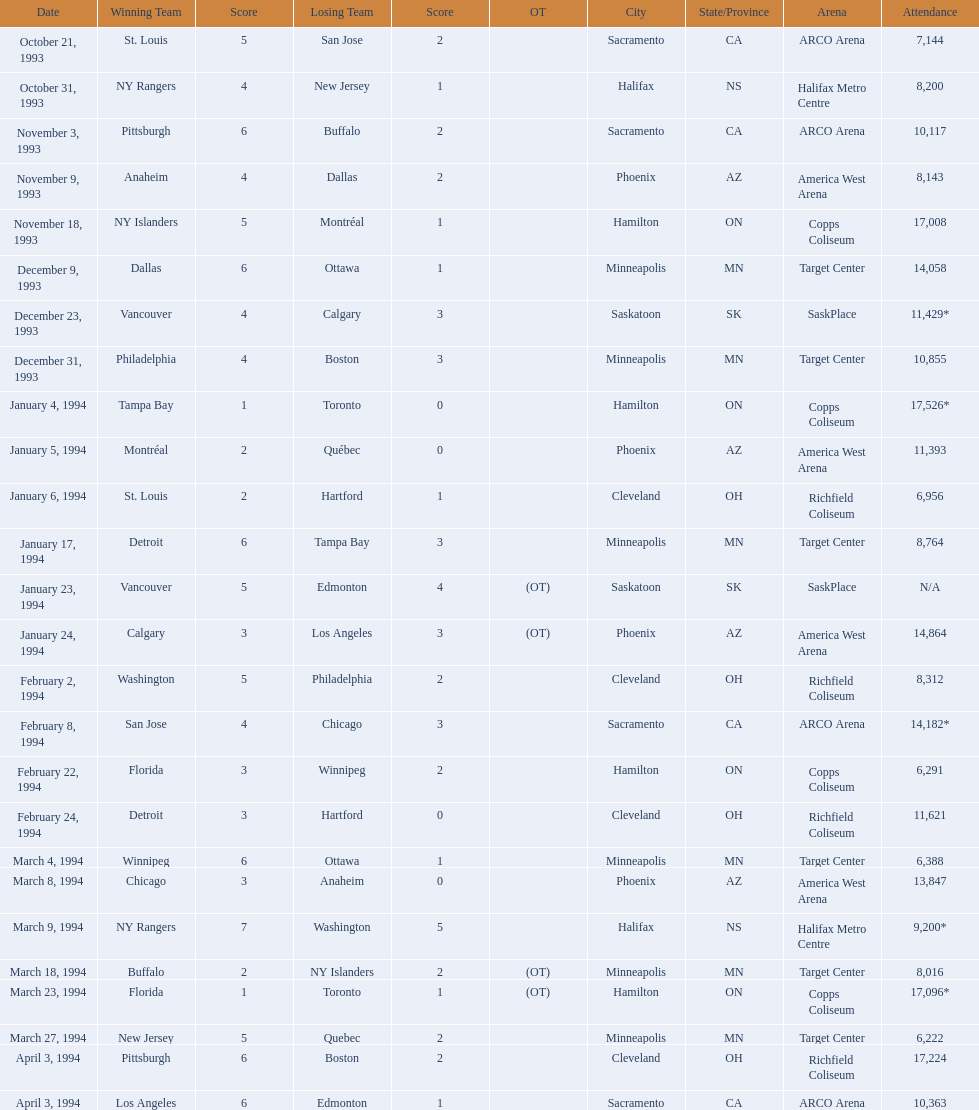What were the dates of the games? October 21, 1993, October 31, 1993, November 3, 1993, November 9, 1993, November 18, 1993, December 9, 1993, December 23, 1993, December 31, 1993, January 4, 1994, January 5, 1994, January 6, 1994, January 17, 1994, January 23, 1994, January 24, 1994, February 2, 1994, February 8, 1994, February 22, 1994, February 24, 1994, March 4, 1994, March 8, 1994, March 9, 1994, March 18, 1994, March 23, 1994, March 27, 1994, April 3, 1994, April 3, 1994. How many people attended each game? 7,144, 8,200, 10,117, 8,143, 17,008, 14,058, 11,429*, 10,855, 17,526*, 11,393, 6,956, 8,764, N/A, 14,864, 8,312, 14,182*, 6,291, 11,621, 6,388, 13,847, 9,200*, 8,016, 17,096*, 6,222, 17,224, 10,363. Which day had the most attendees? January 4, 1994. 